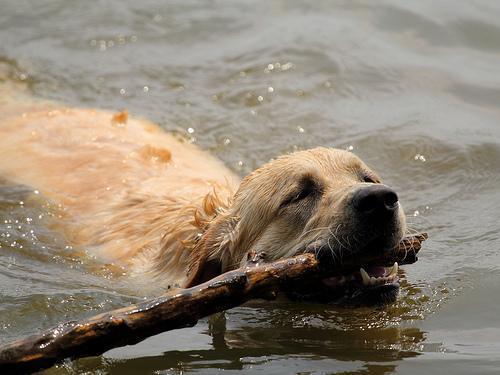How many eyes does the dog have?
Give a very brief answer. 2. How many sticks are the dogs holding?
Give a very brief answer. 1. 